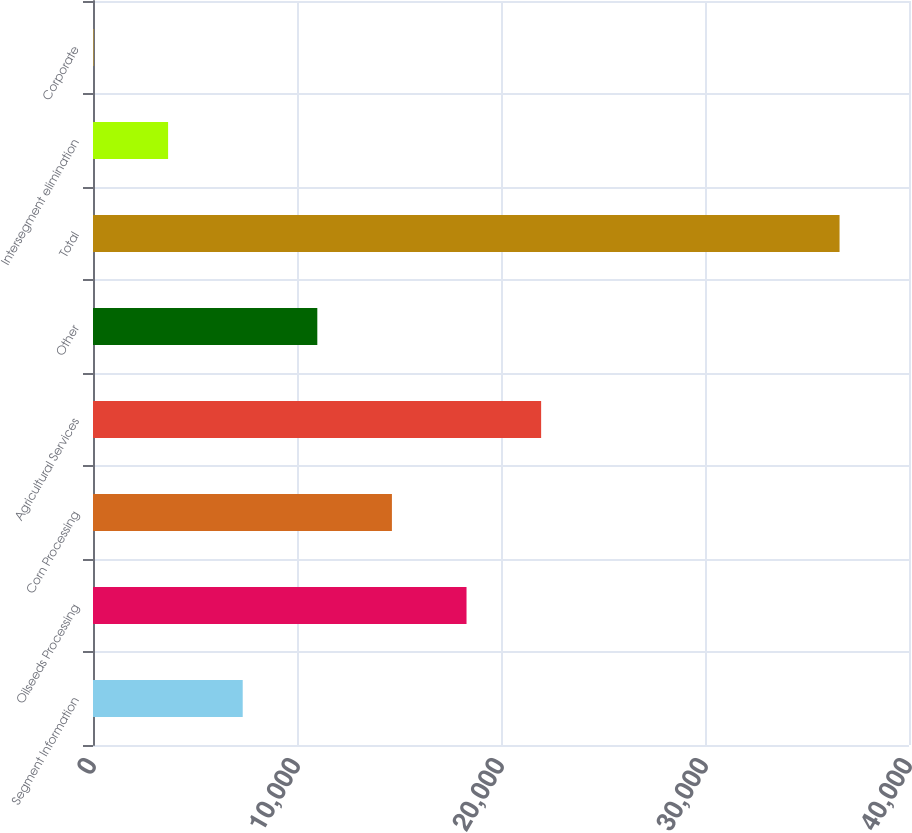<chart> <loc_0><loc_0><loc_500><loc_500><bar_chart><fcel>Segment Information<fcel>Oilseeds Processing<fcel>Corn Processing<fcel>Agricultural Services<fcel>Other<fcel>Total<fcel>Intersegment elimination<fcel>Corporate<nl><fcel>7338.4<fcel>18310<fcel>14652.8<fcel>21967.2<fcel>10995.6<fcel>36596<fcel>3681.2<fcel>24<nl></chart> 